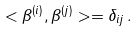<formula> <loc_0><loc_0><loc_500><loc_500>< \beta ^ { ( i ) } , \beta ^ { ( j ) } > = \delta _ { i j } \, .</formula> 